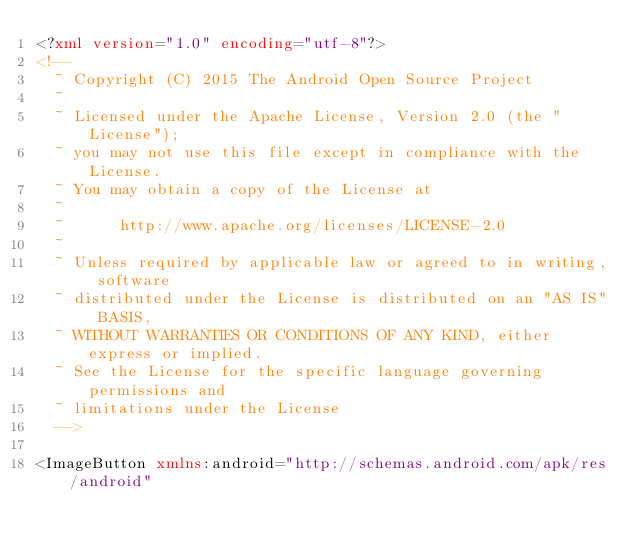Convert code to text. <code><loc_0><loc_0><loc_500><loc_500><_XML_><?xml version="1.0" encoding="utf-8"?>
<!--
  ~ Copyright (C) 2015 The Android Open Source Project
  ~
  ~ Licensed under the Apache License, Version 2.0 (the "License");
  ~ you may not use this file except in compliance with the License.
  ~ You may obtain a copy of the License at
  ~
  ~      http://www.apache.org/licenses/LICENSE-2.0
  ~
  ~ Unless required by applicable law or agreed to in writing, software
  ~ distributed under the License is distributed on an "AS IS" BASIS,
  ~ WITHOUT WARRANTIES OR CONDITIONS OF ANY KIND, either express or implied.
  ~ See the License for the specific language governing permissions and
  ~ limitations under the License
  -->

<ImageButton xmlns:android="http://schemas.android.com/apk/res/android"</code> 